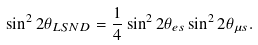Convert formula to latex. <formula><loc_0><loc_0><loc_500><loc_500>\sin ^ { 2 } 2 \theta _ { L S N D } = \frac { 1 } { 4 } \sin ^ { 2 } 2 \theta _ { e s } \sin ^ { 2 } 2 \theta _ { \mu s } .</formula> 